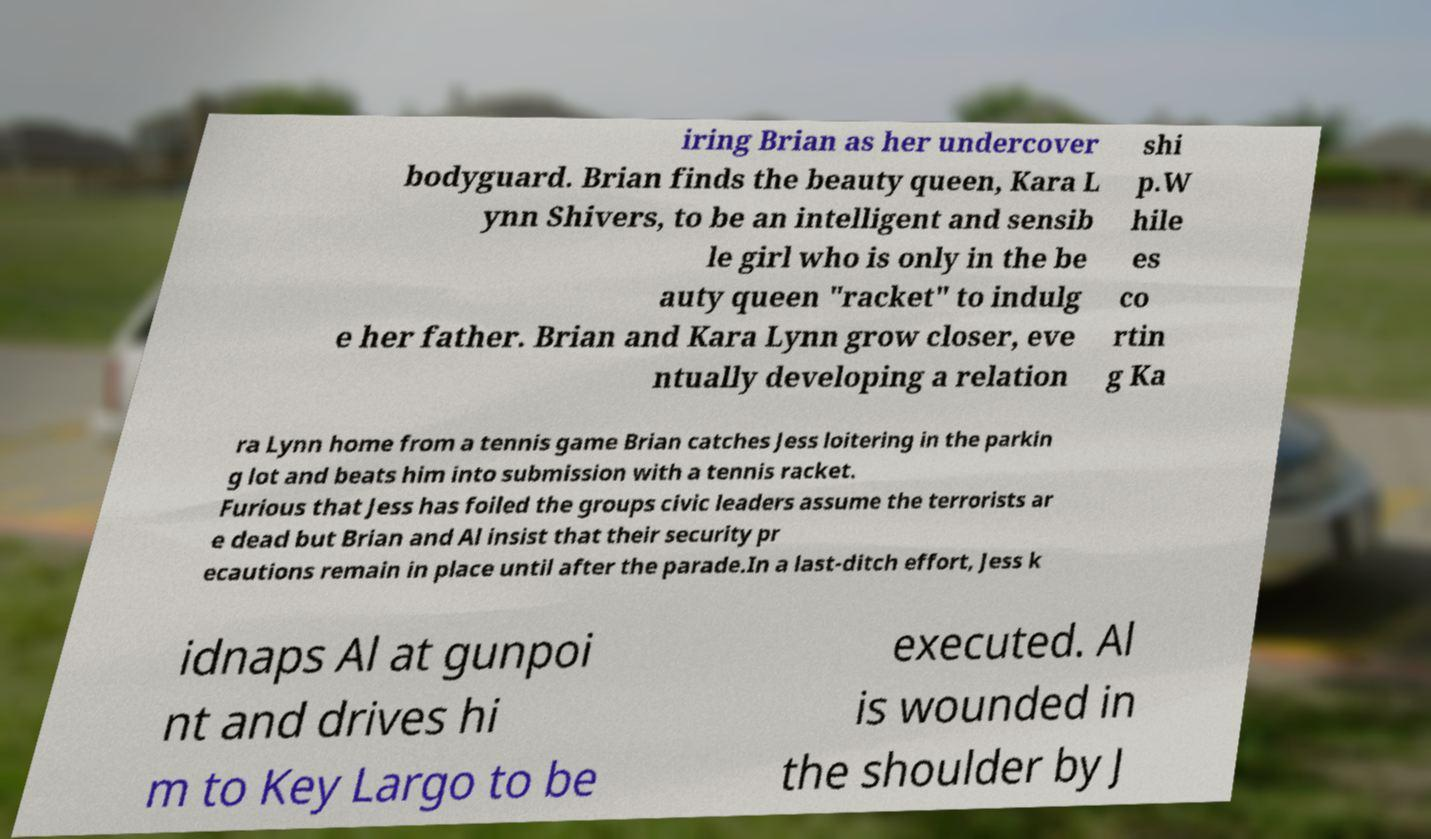Could you extract and type out the text from this image? iring Brian as her undercover bodyguard. Brian finds the beauty queen, Kara L ynn Shivers, to be an intelligent and sensib le girl who is only in the be auty queen "racket" to indulg e her father. Brian and Kara Lynn grow closer, eve ntually developing a relation shi p.W hile es co rtin g Ka ra Lynn home from a tennis game Brian catches Jess loitering in the parkin g lot and beats him into submission with a tennis racket. Furious that Jess has foiled the groups civic leaders assume the terrorists ar e dead but Brian and Al insist that their security pr ecautions remain in place until after the parade.In a last-ditch effort, Jess k idnaps Al at gunpoi nt and drives hi m to Key Largo to be executed. Al is wounded in the shoulder by J 